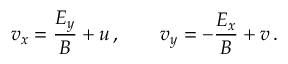Convert formula to latex. <formula><loc_0><loc_0><loc_500><loc_500>v _ { x } = \frac { E _ { y } } { B } + u \, , \quad v _ { y } = - \frac { E _ { x } } { B } + v \, .</formula> 